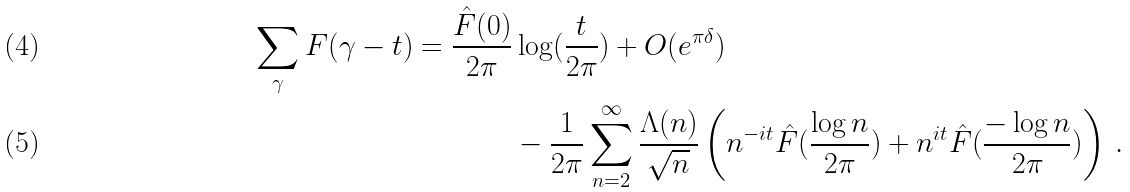<formula> <loc_0><loc_0><loc_500><loc_500>\sum _ { \gamma } F ( \gamma - t ) = \frac { \hat { F } ( 0 ) } { 2 \pi } & \log ( \frac { t } { 2 \pi } ) + O ( e ^ { \pi \delta } ) \\ & - \frac { 1 } { 2 \pi } \sum _ { n = 2 } ^ { \infty } \frac { \Lambda ( n ) } { \sqrt { n } } \left ( n ^ { - i t } \hat { F } ( \frac { \log n } { 2 \pi } ) + n ^ { i t } \hat { F } ( \frac { - \log n } { 2 \pi } ) \right ) \, .</formula> 